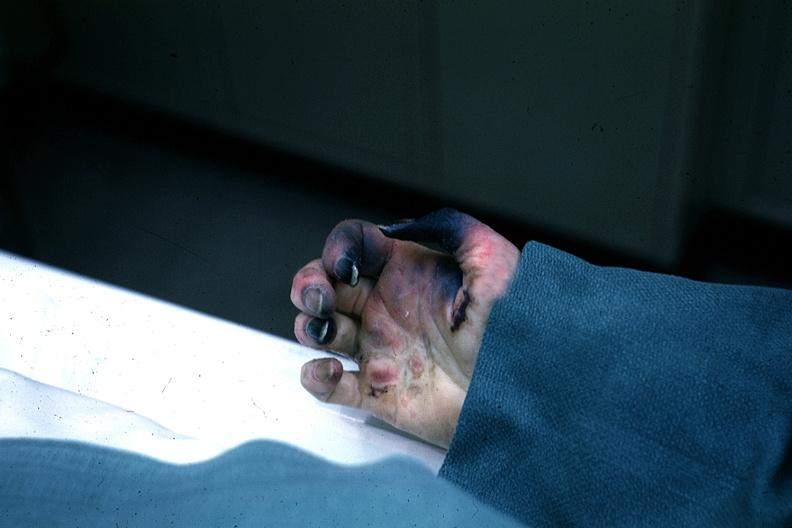what are present?
Answer the question using a single word or phrase. Extremities 